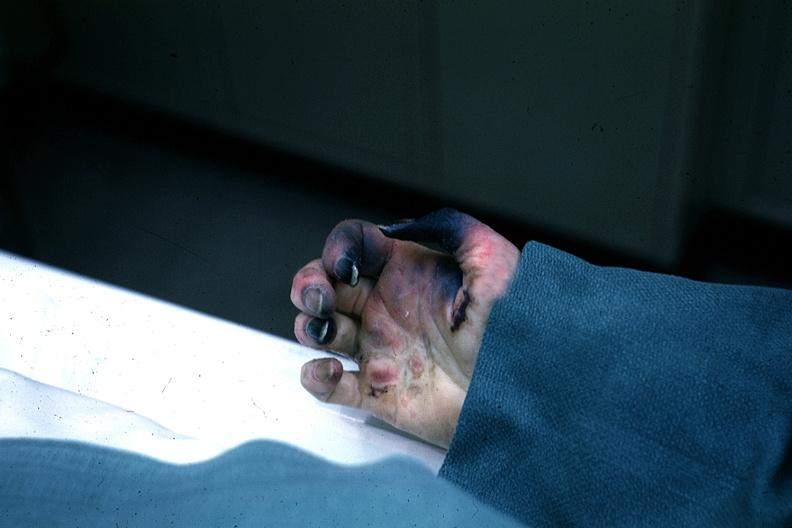what are present?
Answer the question using a single word or phrase. Extremities 